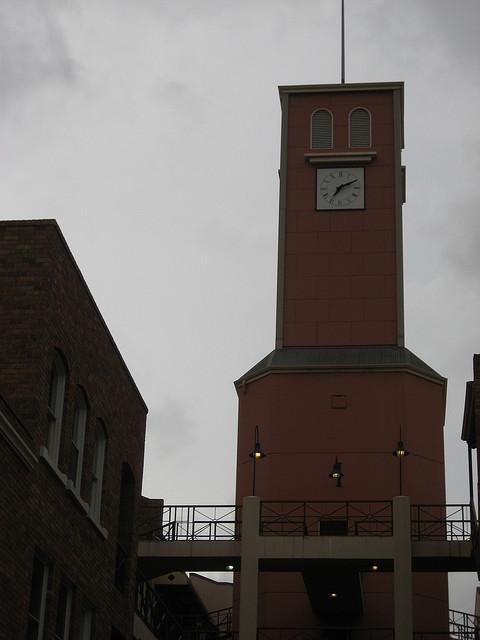Where is the clock?
Keep it brief. On tower. Is there a balcony?
Answer briefly. Yes. What time it is?
Keep it brief. 7:10. Is the sun glaring in the photo?
Short answer required. No. What is the place of this structure?
Short answer required. Clock tower. 